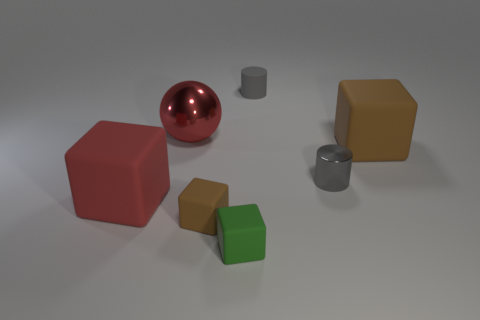Can you tell me the colors of the cube-shaped objects in the image? Certainly! There are three cube-shaped objects in the image. One is red, another is brown, and the third one is green. 